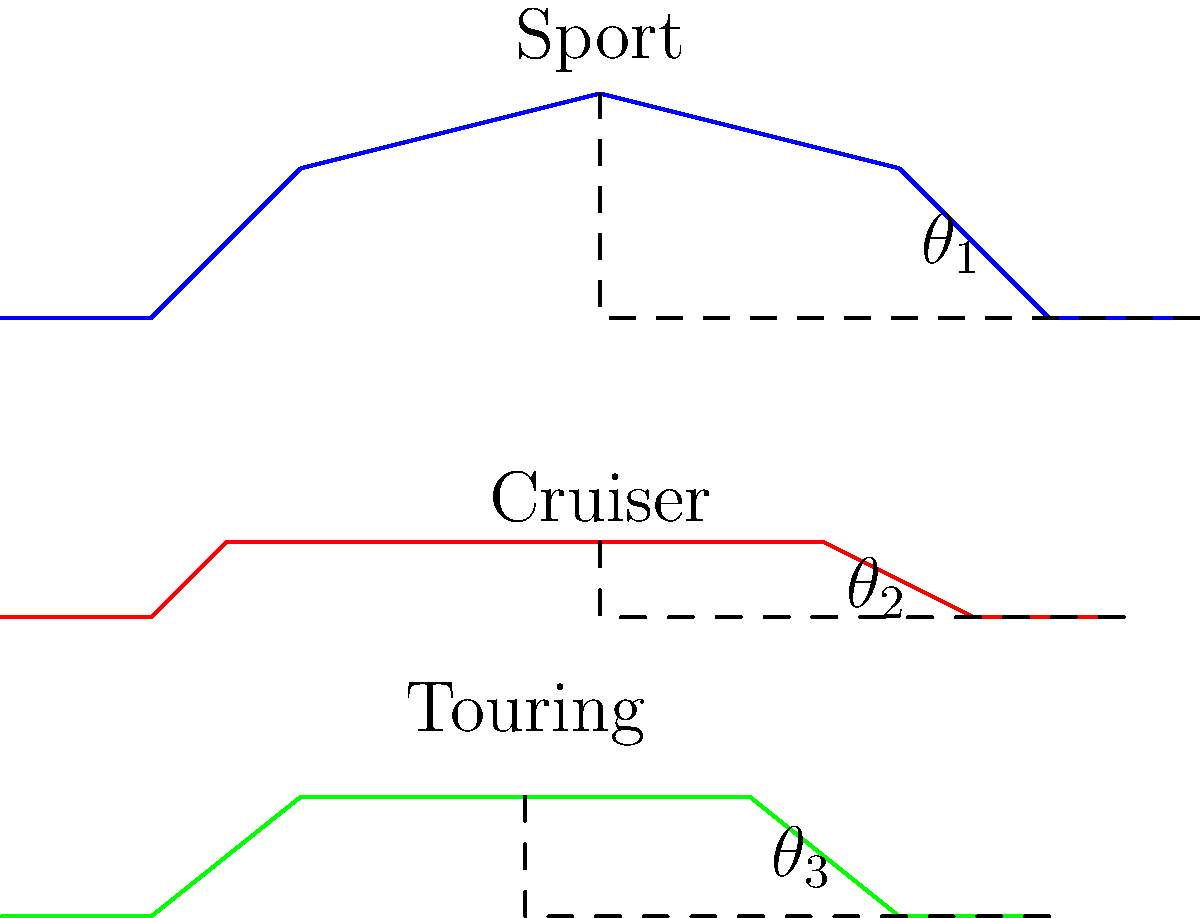Based on your extensive experience reviewing motorcycles, which type of motorcycle typically has the largest lean angle, and how does this affect its performance characteristics? To answer this question, we need to consider the lean angles depicted in the diagram and relate them to motorcycle performance:

1. Observe the side-view silhouettes of three motorcycle types: sport, cruiser, and touring.

2. The lean angle is represented by the angle between the vertical line and the line connecting the center of the motorcycle to its outermost point.

3. Comparing the angles:
   $\theta_1$ (sport) > $\theta_3$ (touring) > $\theta_2$ (cruiser)

4. Sport motorcycles typically have the largest lean angle ($\theta_1$) due to their design focusing on performance and agility.

5. Larger lean angles allow for:
   a) Tighter cornering at higher speeds
   b) Improved maneuverability in twisty roads
   c) Better performance on race tracks

6. The large lean angle in sport bikes is achieved through:
   a) Higher ground clearance
   b) Centralized mass
   c) Sporty ergonomics

7. However, larger lean angles can also result in:
   a) Less stability at lower speeds
   b) More challenging riding position for beginners
   c) Reduced comfort for long-distance riding

In conclusion, sport motorcycles typically have the largest lean angle, which significantly enhances their cornering ability and overall performance in high-speed, dynamic riding situations.
Answer: Sport motorcycles; larger lean angles enable tighter cornering and improved maneuverability at high speeds. 